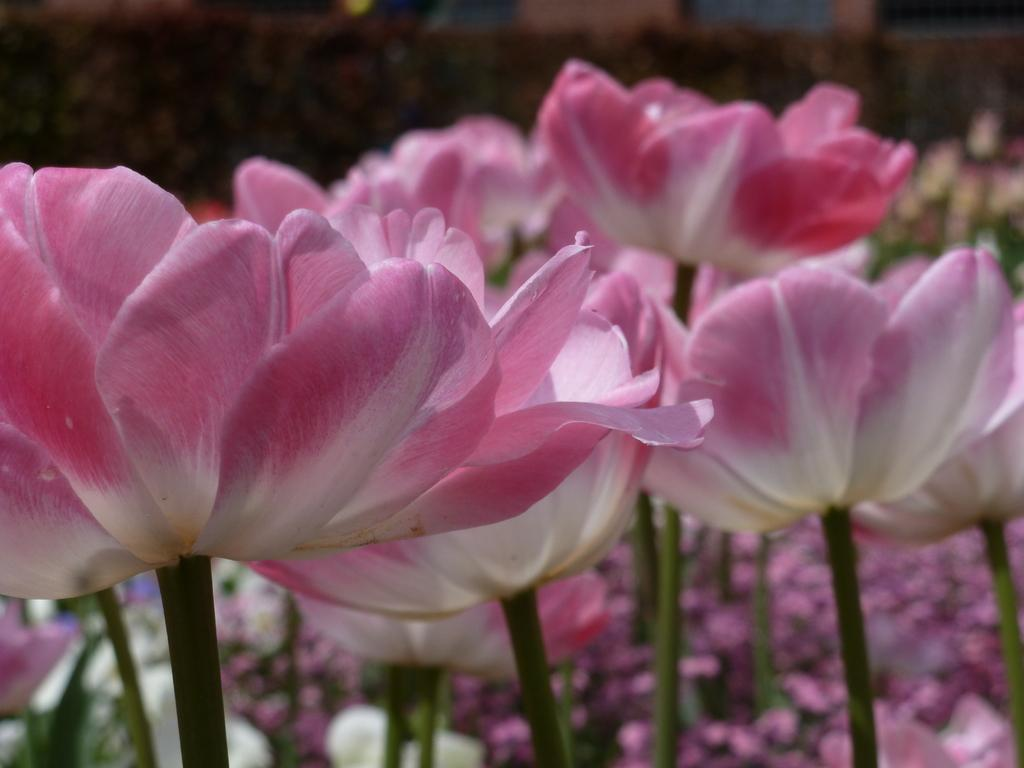What type of plants can be seen in the image? There are plants with flowers in the image. What can be seen in the background of the image? There are objects in the background of the image. How is the background of the image depicted? The background of the image is blurred. What type of war is being fought in the background of the image? There is no war present in the image; the background is blurred and contains objects, but no conflict is depicted. 